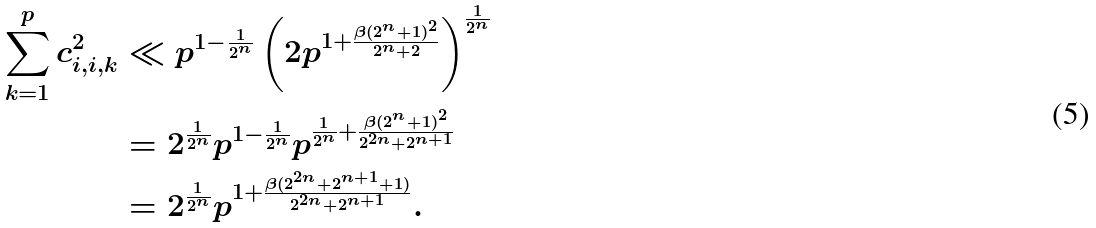Convert formula to latex. <formula><loc_0><loc_0><loc_500><loc_500>\sum _ { k = 1 } ^ { p } c _ { i , i , k } ^ { 2 } & \ll p ^ { 1 - \frac { 1 } { 2 ^ { n } } } \left ( 2 p ^ { 1 + \frac { \beta ( 2 ^ { n } + 1 ) ^ { 2 } } { 2 ^ { n } + 2 } } \right ) ^ { \frac { 1 } { 2 ^ { n } } } \\ & = 2 ^ { \frac { 1 } { 2 ^ { n } } } p ^ { 1 - \frac { 1 } { 2 ^ { n } } } p ^ { \frac { 1 } { 2 ^ { n } } + \frac { \beta ( 2 ^ { n } + 1 ) ^ { 2 } } { 2 ^ { 2 n } + 2 ^ { n + 1 } } } \\ & = 2 ^ { \frac { 1 } { 2 ^ { n } } } p ^ { 1 + \frac { \beta ( 2 ^ { 2 n } + 2 ^ { n + 1 } + 1 ) } { 2 ^ { 2 n } + 2 ^ { n + 1 } } } .</formula> 